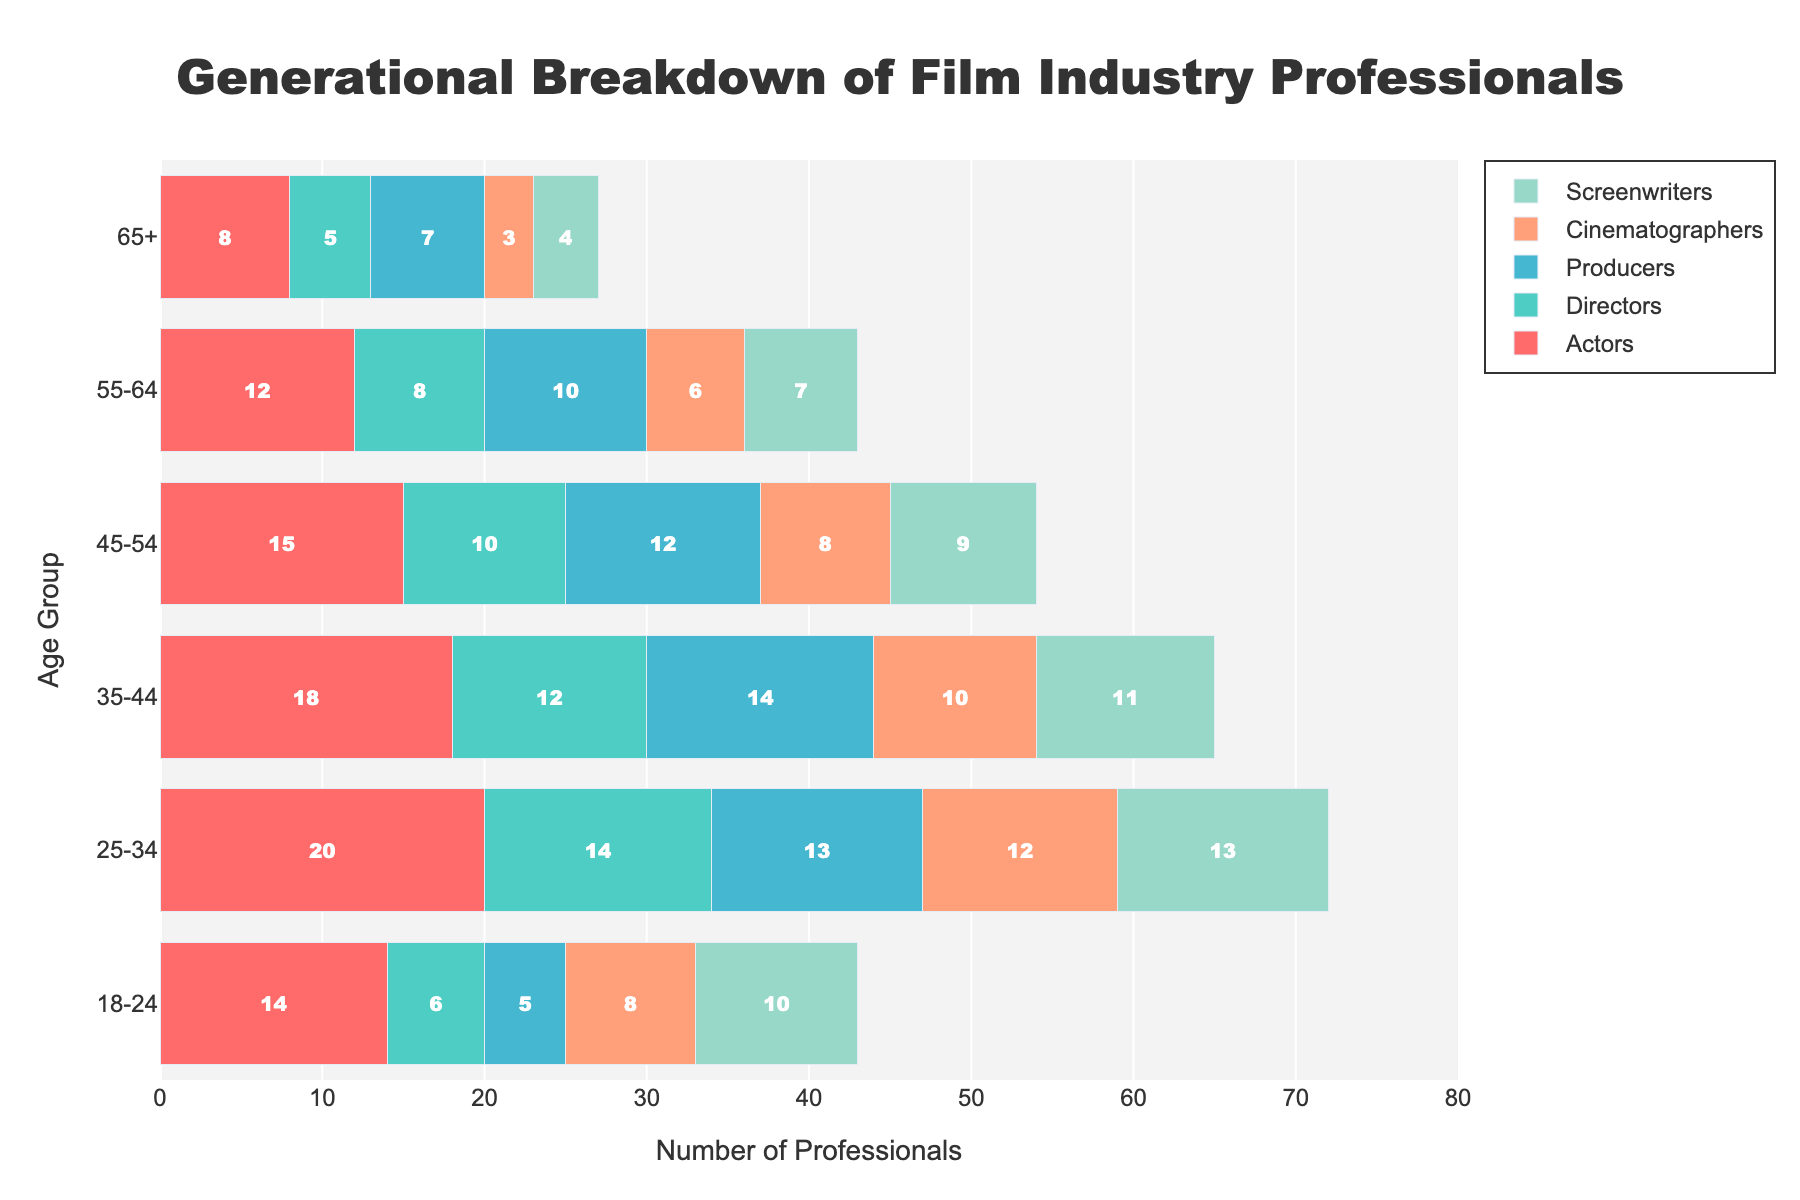What is the title of the population pyramid? The title of the plot is usually located at the top, centered in this case. It reads "Generational Breakdown of Film Industry Professionals".
Answer: Generational Breakdown of Film Industry Professionals Which department has the largest number of professionals in the 25-34 age group? To find this, look for the age group '25-34' on the y-axis and compare the lengths of the bars for each department. The bar for 'Actors' is the longest.
Answer: Actors How many Directors are in the age group 45-54? Refer to the '45-54' age group and find the value associated with the 'Directors' bar. The bar's text indicates 10.
Answer: 10 What is the total number of Producers across all age groups? Add the numbers of Producers across all age groups: 7 (65+) + 10 (55-64) + 12 (45-54) + 14 (35-44) + 13 (25-34) + 5 (18-24). The total is 61.
Answer: 61 Which age group has the least number of Cinematographers? Compare the lengths of the Cinematographers' bars across all age groups. The shortest bar corresponds with the age group '65+' at 3.
Answer: 65+ Are there more Screenwriters in the 18-24 age group or Directors in the same age group? Compare the lengths of the bars for 'Screenwriters' and 'Directors' within the '18-24' age group. Screenwriters have a count of 10, while Directors have a count of 6.
Answer: Screenwriters How many more Actors are there in the 25-34 age group compared to the 18-24 age group? Subtract the number of Actors in the '18-24' age group (14) from the number in the '25-34' age group (20). The difference is 6.
Answer: 6 Which department experiences the most significant generational shift in numbers from the 25-34 age group to the 65+ group? Observe the bars from the '25-34' and '65+' age groups for each department and identify the largest drop. Actors drop from 20 (25-34) to 8 (65+), which is a significant shift of 12.
Answer: Actors What's the average number of professionals in the age group 55-64 across all departments? Add the numbers for the '55-64' age group and divide by 5 (number of departments): (12 + 8 + 10 + 6 + 7) / 5 = 43 / 5 = 8.6.
Answer: 8.6 Which age group has the highest total number of professionals combined across all departments? Sum the counts for all departments in each age group and compare. 25-34 (20+14+13+12+13=72) has the highest total number of professionals.
Answer: 25-34 